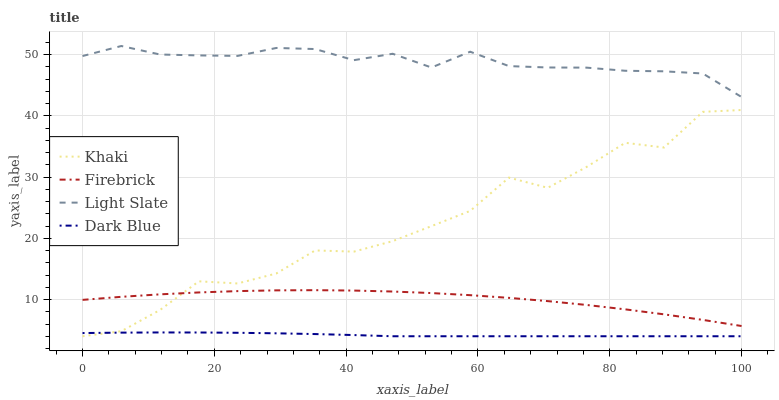Does Dark Blue have the minimum area under the curve?
Answer yes or no. Yes. Does Light Slate have the maximum area under the curve?
Answer yes or no. Yes. Does Firebrick have the minimum area under the curve?
Answer yes or no. No. Does Firebrick have the maximum area under the curve?
Answer yes or no. No. Is Dark Blue the smoothest?
Answer yes or no. Yes. Is Khaki the roughest?
Answer yes or no. Yes. Is Firebrick the smoothest?
Answer yes or no. No. Is Firebrick the roughest?
Answer yes or no. No. Does Dark Blue have the lowest value?
Answer yes or no. Yes. Does Firebrick have the lowest value?
Answer yes or no. No. Does Light Slate have the highest value?
Answer yes or no. Yes. Does Firebrick have the highest value?
Answer yes or no. No. Is Dark Blue less than Firebrick?
Answer yes or no. Yes. Is Firebrick greater than Dark Blue?
Answer yes or no. Yes. Does Khaki intersect Dark Blue?
Answer yes or no. Yes. Is Khaki less than Dark Blue?
Answer yes or no. No. Is Khaki greater than Dark Blue?
Answer yes or no. No. Does Dark Blue intersect Firebrick?
Answer yes or no. No. 